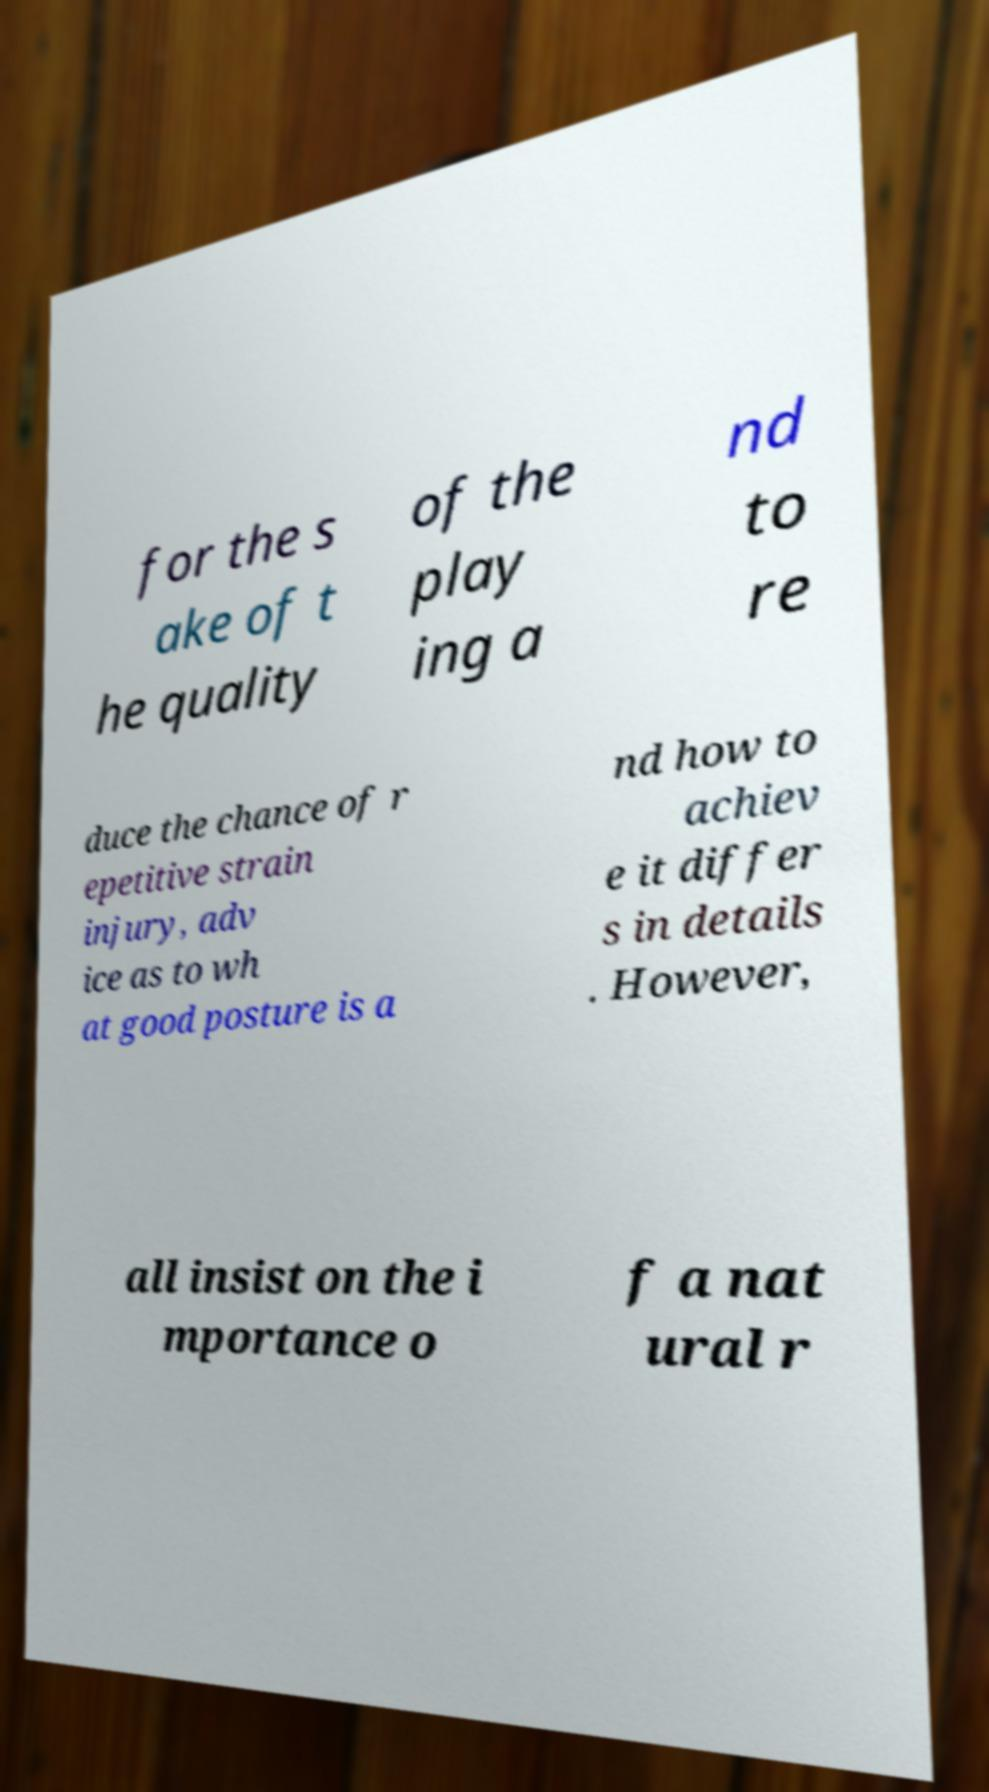Could you assist in decoding the text presented in this image and type it out clearly? for the s ake of t he quality of the play ing a nd to re duce the chance of r epetitive strain injury, adv ice as to wh at good posture is a nd how to achiev e it differ s in details . However, all insist on the i mportance o f a nat ural r 